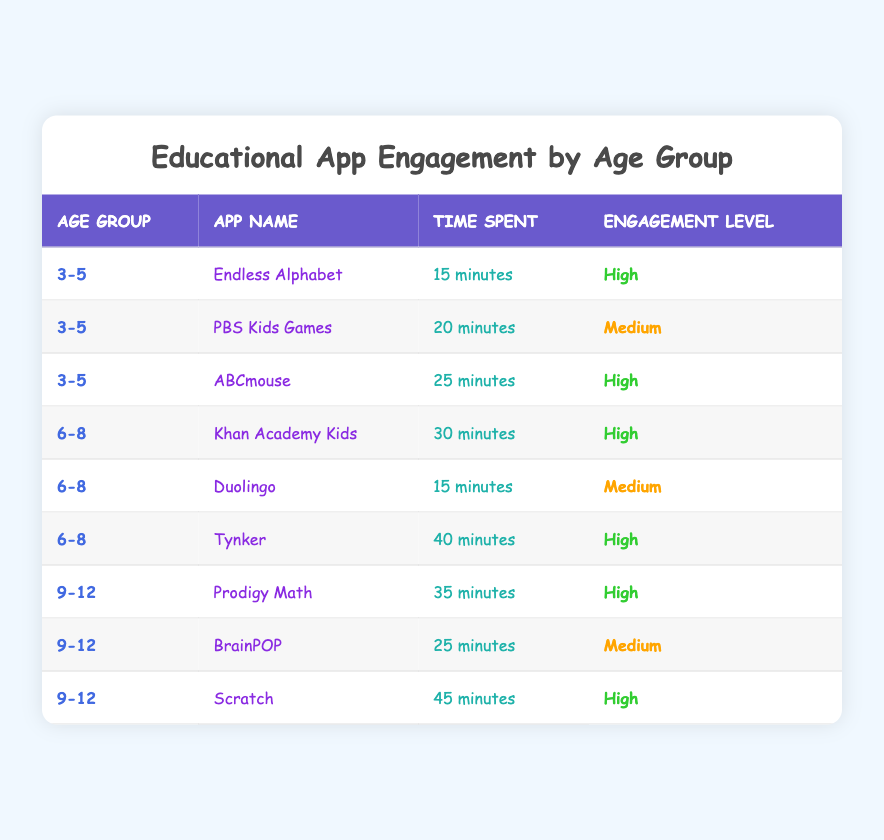What is the engagement level of "Endless Alphabet"? The app "Endless Alphabet" is listed in the table under the age group "3-5" with an engagement level marked as "High."
Answer: High Which age group spent the most time on educational apps? The maximum time spent in the table is 45 minutes on the app "Scratch," which belongs to the age group "9-12." Thus, this age group has the highest recorded time spent.
Answer: 9-12 How many apps show a high engagement level in the "6-8" age group? The "6-8" age group has two apps with a high engagement level: "Khan Academy Kids" and "Tynker." Counting these provides the answer.
Answer: 2 Is there any app in the "3-5" age group with a medium engagement level? Yes, the app "PBS Kids Games" falls under the "3-5" age group with an engagement level marked as "Medium."
Answer: Yes What is the average time spent on apps with a high engagement level across all age groups? The high engagement apps are: "Endless Alphabet" (15 min), "ABCmouse" (25 min), "Khan Academy Kids" (30 min), "Tynker" (40 min), "Prodigy Math" (35 min), and "Scratch" (45 min). Adding these times gives a total of 15 + 25 + 30 + 40 + 35 + 45 = 190 minutes. There are 6 high engagement apps, so the average is 190 / 6 = ~31.67 minutes.
Answer: ~31.67 minutes Which app had the shortest time spent in the "3-5" age group with a high engagement level? In the "3-5" age group section of the table, the app with a high engagement level that is noted for the shortest time spent is "Endless Alphabet" with 15 minutes.
Answer: Endless Alphabet How many apps in total have a medium engagement level, and what are their names? In the table, two apps are listed with medium engagement: "PBS Kids Games" (3-5 age group) and "BrainPOP" (9-12 age group). Summing these gives two apps total.
Answer: 2 apps: PBS Kids Games, BrainPOP Was "Duolingo" rated as high engagement in the "6-8" age group? No, "Duolingo" has a medium engagement level, as indicated next to the app name in the "6-8" age group of the table.
Answer: No What is the total number of educational apps reviewed in the table? The table shows a total of 8 different educational apps listed for varying age groups, each counted from the entries provided.
Answer: 8 apps 